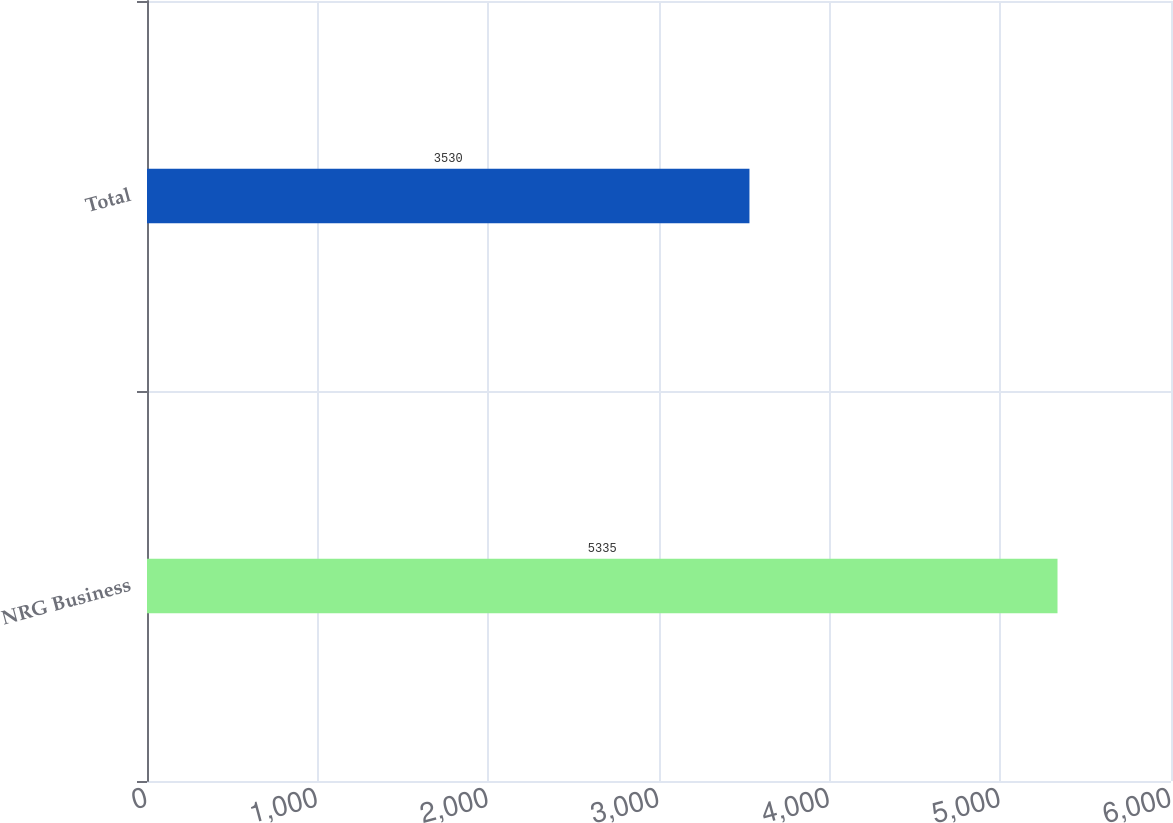<chart> <loc_0><loc_0><loc_500><loc_500><bar_chart><fcel>NRG Business<fcel>Total<nl><fcel>5335<fcel>3530<nl></chart> 